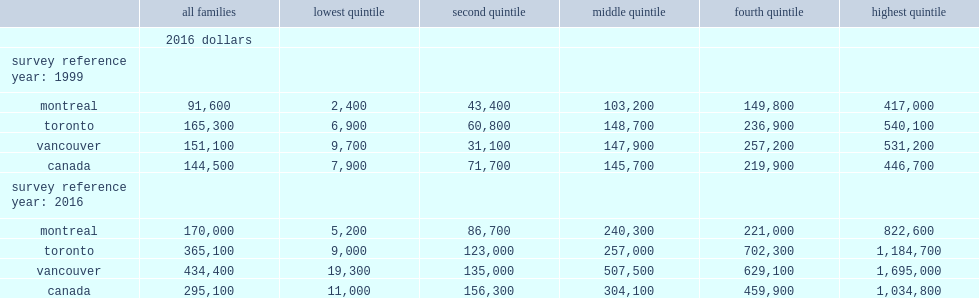I'm looking to parse the entire table for insights. Could you assist me with that? {'header': ['', 'all families', 'lowest quintile', 'second quintile', 'middle quintile', 'fourth quintile', 'highest quintile'], 'rows': [['', '2016 dollars', '', '', '', '', ''], ['survey reference year: 1999', '', '', '', '', '', ''], ['montreal', '91,600', '2,400', '43,400', '103,200', '149,800', '417,000'], ['toronto', '165,300', '6,900', '60,800', '148,700', '236,900', '540,100'], ['vancouver', '151,100', '9,700', '31,100', '147,900', '257,200', '531,200'], ['canada', '144,500', '7,900', '71,700', '145,700', '219,900', '446,700'], ['survey reference year: 2016', '', '', '', '', '', ''], ['montreal', '170,000', '5,200', '86,700', '240,300', '221,000', '822,600'], ['toronto', '365,100', '9,000', '123,000', '257,000', '702,300', '1,184,700'], ['vancouver', '434,400', '19,300', '135,000', '507,500', '629,100', '1,695,000'], ['canada', '295,100', '11,000', '156,300', '304,100', '459,900', '1,034,800']]} How much is the median wealth of families in the lowest income quintile in vancouver in 2016? 19300.0. How much is the median wealth of families in the lowest income quintile in toronto in 2016? 9000.0. How much is the median wealth of families in the lowest income quintile in montreal in 2016? 5200.0. How much is the median wealth of top-quintile families in vancouver in 2016? 1695000.0. How much higher is the median net wealth of top-quintile families in vancouver than that among top-earning families in toronto in 2016? 0.430742. How many times is the median net wealth of top-quintile families in vancouver higher than that among top-income families in montreal in 2016? 2.06054. 